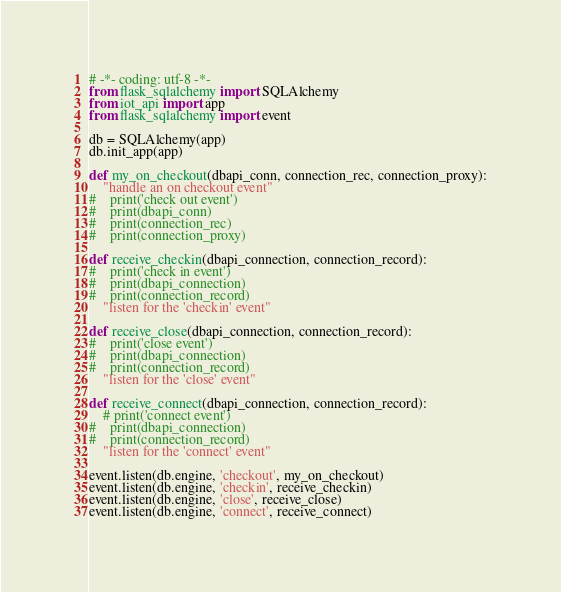<code> <loc_0><loc_0><loc_500><loc_500><_Python_># -*- coding: utf-8 -*-
from flask_sqlalchemy import SQLAlchemy
from iot_api import app
from flask_sqlalchemy import event

db = SQLAlchemy(app)
db.init_app(app)

def my_on_checkout(dbapi_conn, connection_rec, connection_proxy):
    "handle an on checkout event"
#    print('check out event')
#    print(dbapi_conn)
#    print(connection_rec)
#    print(connection_proxy)

def receive_checkin(dbapi_connection, connection_record):
#    print('check in event')
#    print(dbapi_connection)
#    print(connection_record)
    "listen for the 'checkin' event"

def receive_close(dbapi_connection, connection_record):
#    print('close event')
#    print(dbapi_connection)
#    print(connection_record)
    "listen for the 'close' event"

def receive_connect(dbapi_connection, connection_record):
    # print('connect event')
#    print(dbapi_connection)
#    print(connection_record)
    "listen for the 'connect' event"

event.listen(db.engine, 'checkout', my_on_checkout)
event.listen(db.engine, 'checkin', receive_checkin)
event.listen(db.engine, 'close', receive_close)
event.listen(db.engine, 'connect', receive_connect)


</code> 